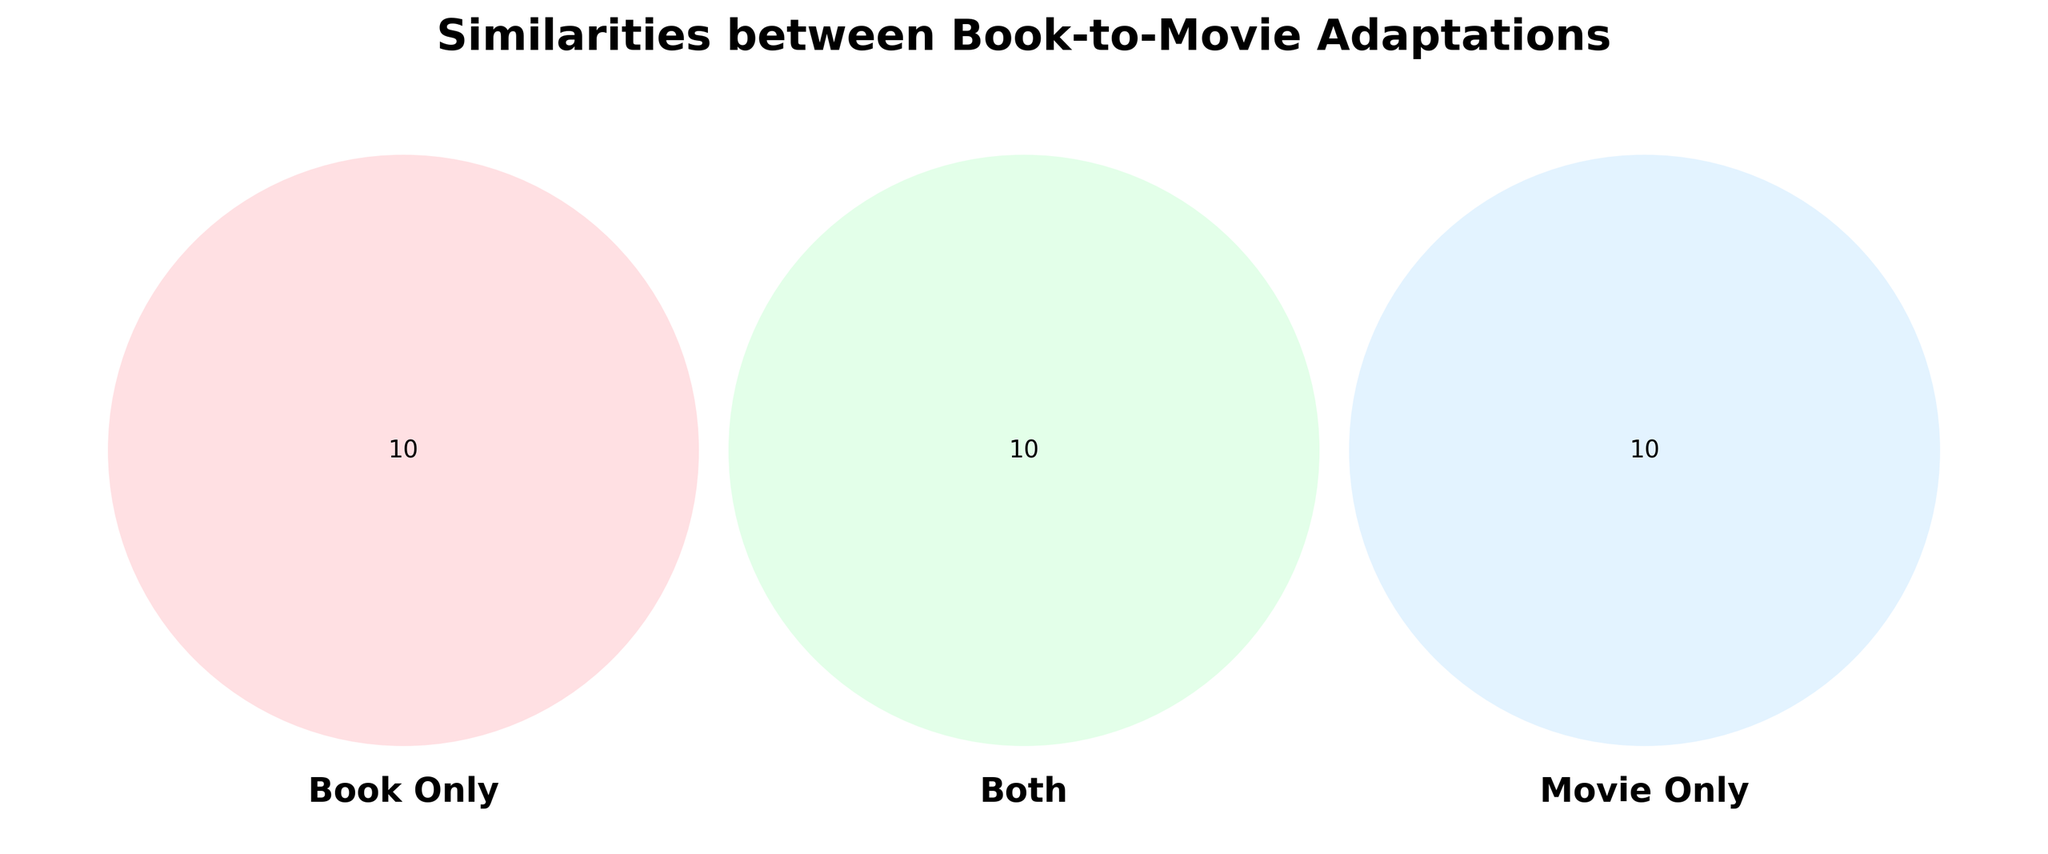What is the title of the Venn Diagram? The title is typically placed at the top of the figure and is in bold. It provides the main theme or subject of the diagram.
Answer: Similarities between Book-to-Movie Adaptations What overlaps between the book and movie versions of 'The Hunger Games'? Look at the intersection labeled 'Both' for 'The Hunger Games' and see what is common between book and movie versions.
Answer: Dystopian society Which adaptation overlaps in terms of 'Romance'? Check the elements in the intersection labeled 'Both' for Romance.
Answer: Pride and Prejudice Which category has the most distinctive characteristics for 'To Kill a Mockingbird'? Compare the number of listed characteristics under 'Book Only', 'Both', and 'Movie Only'. The one with the most entries is the most distinctive.
Answer: Book Only What's unique to movies in 'Jurassic Park' that isn't found in the books? Look at 'Movie Only' section under 'Jurassic Park'.
Answer: CGI effects How many adaptations share elements under 'Both'? Count the number of entries in the 'Both' section for all adaptations.
Answer: 10 Which of the listed adaptations has 'Symbology' as a shared characteristic? Review the elements in the 'Both' section and identify which adaptation contains 'Symbology'.
Answer: The Da Vinci Code Which adaptations include 'Extended battle scenes' in their movies but not in their books? Look at the 'Movie Only' section and find 'Extended battle scenes'.
Answer: The Lord of the Rings For 'The Great Gatsby', what unique feature does the movie have that the book does not? Check the 'Movie Only' section under 'The Great Gatsby'.
Answer: Jazz soundtrack 